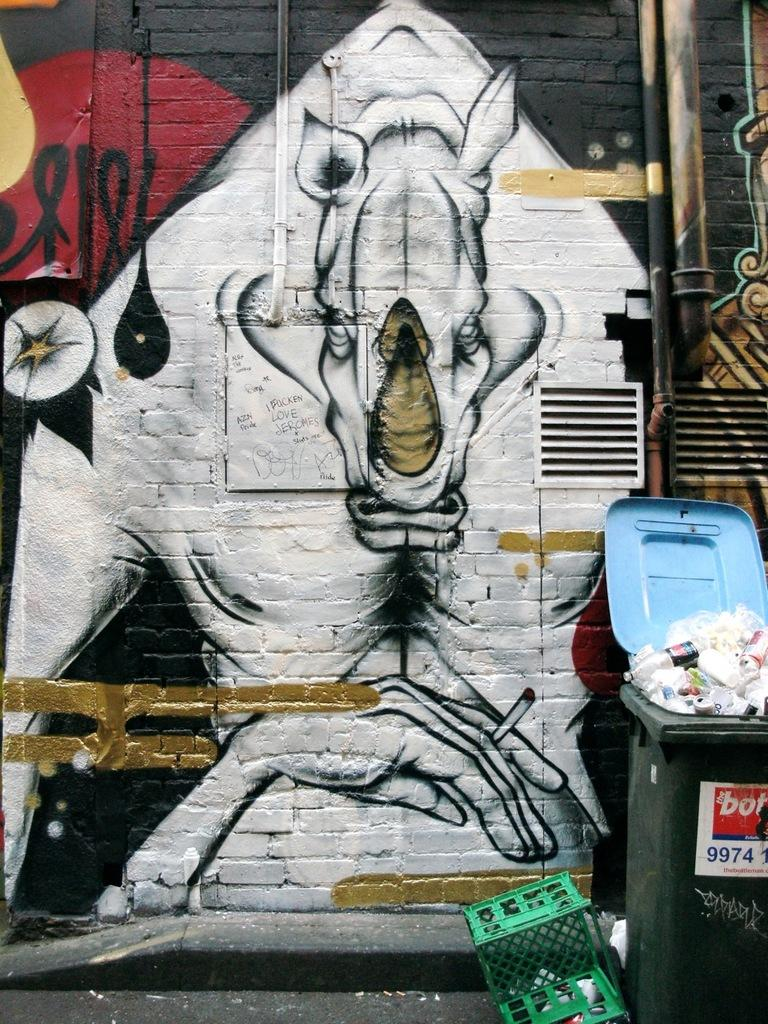Provide a one-sentence caption for the provided image. the numbers 9974 are on the front of a trash can. 